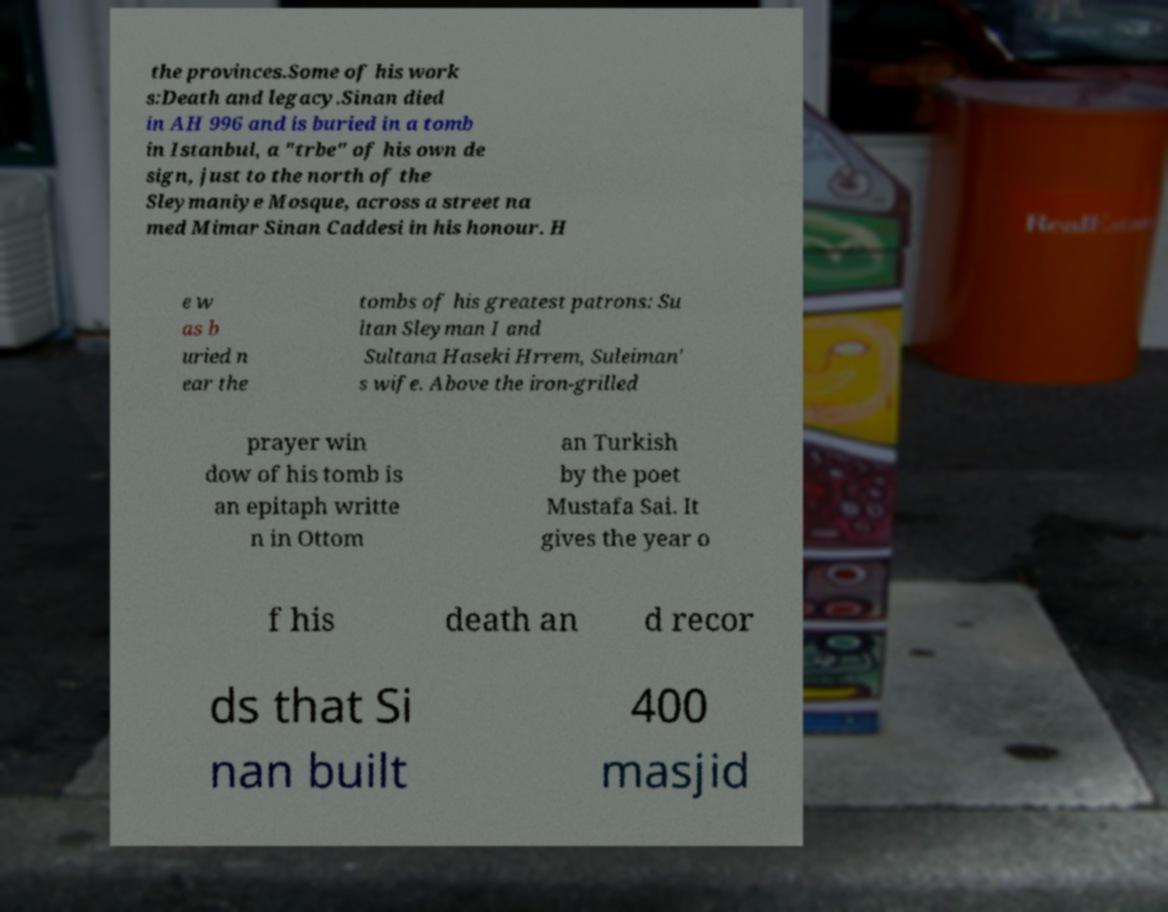There's text embedded in this image that I need extracted. Can you transcribe it verbatim? the provinces.Some of his work s:Death and legacy.Sinan died in AH 996 and is buried in a tomb in Istanbul, a "trbe" of his own de sign, just to the north of the Sleymaniye Mosque, across a street na med Mimar Sinan Caddesi in his honour. H e w as b uried n ear the tombs of his greatest patrons: Su ltan Sleyman I and Sultana Haseki Hrrem, Suleiman' s wife. Above the iron-grilled prayer win dow of his tomb is an epitaph writte n in Ottom an Turkish by the poet Mustafa Sai. It gives the year o f his death an d recor ds that Si nan built 400 masjid 